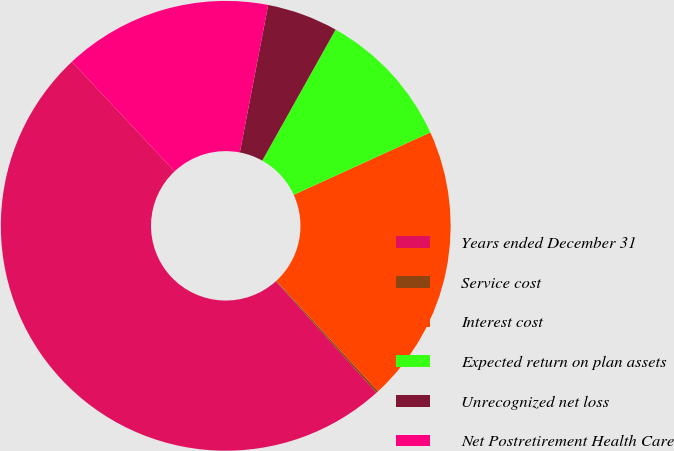<chart> <loc_0><loc_0><loc_500><loc_500><pie_chart><fcel>Years ended December 31<fcel>Service cost<fcel>Interest cost<fcel>Expected return on plan assets<fcel>Unrecognized net loss<fcel>Net Postretirement Health Care<nl><fcel>49.7%<fcel>0.15%<fcel>19.97%<fcel>10.06%<fcel>5.1%<fcel>15.01%<nl></chart> 